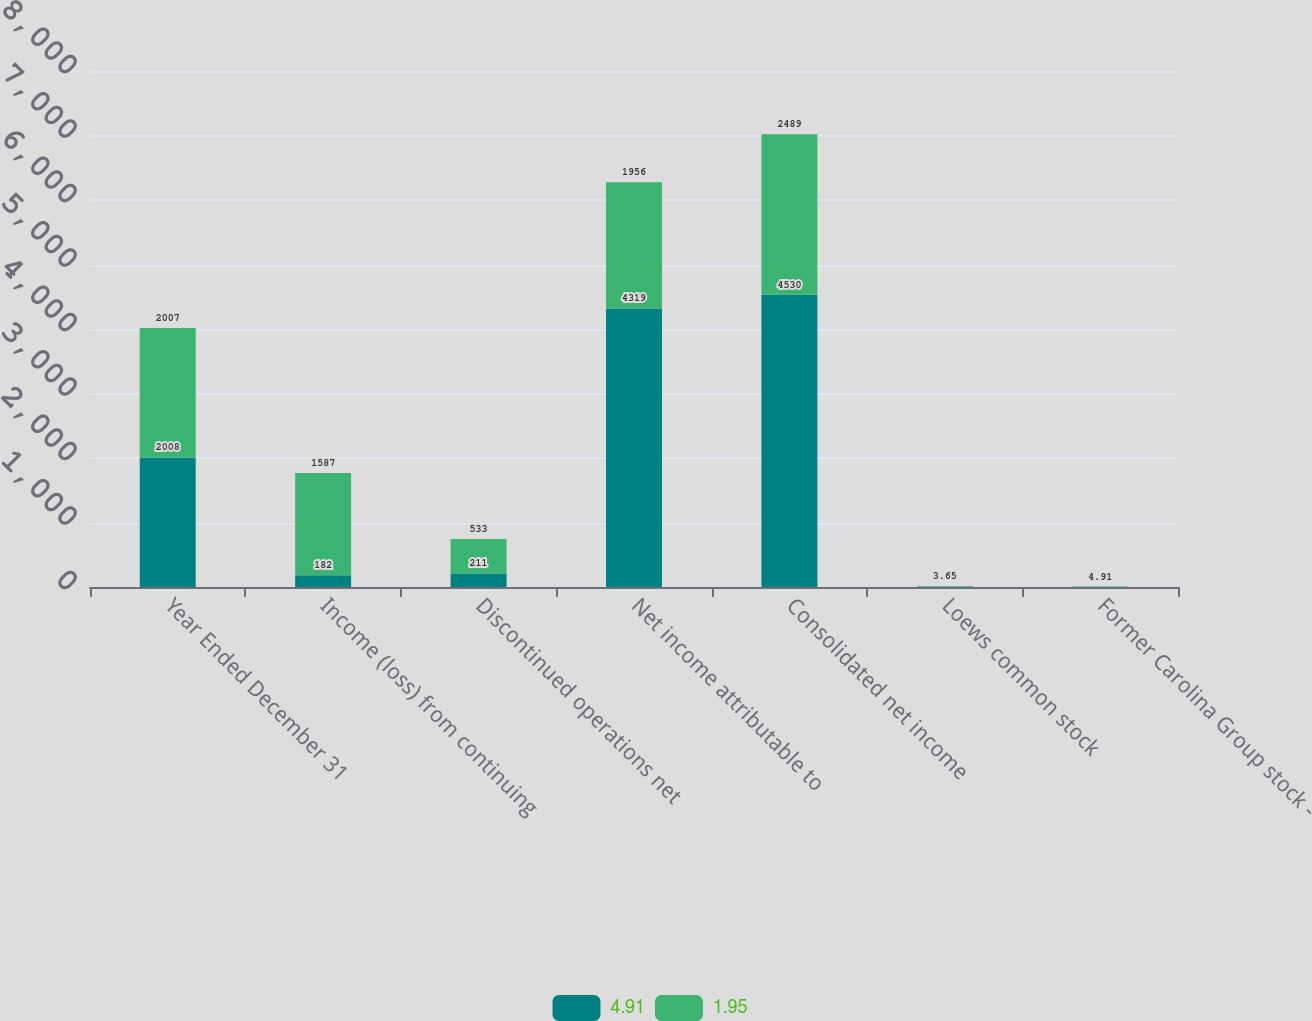Convert chart. <chart><loc_0><loc_0><loc_500><loc_500><stacked_bar_chart><ecel><fcel>Year Ended December 31<fcel>Income (loss) from continuing<fcel>Discontinued operations net<fcel>Net income attributable to<fcel>Consolidated net income<fcel>Loews common stock<fcel>Former Carolina Group stock -<nl><fcel>4.91<fcel>2008<fcel>182<fcel>211<fcel>4319<fcel>4530<fcel>9.05<fcel>1.95<nl><fcel>1.95<fcel>2007<fcel>1587<fcel>533<fcel>1956<fcel>2489<fcel>3.65<fcel>4.91<nl></chart> 